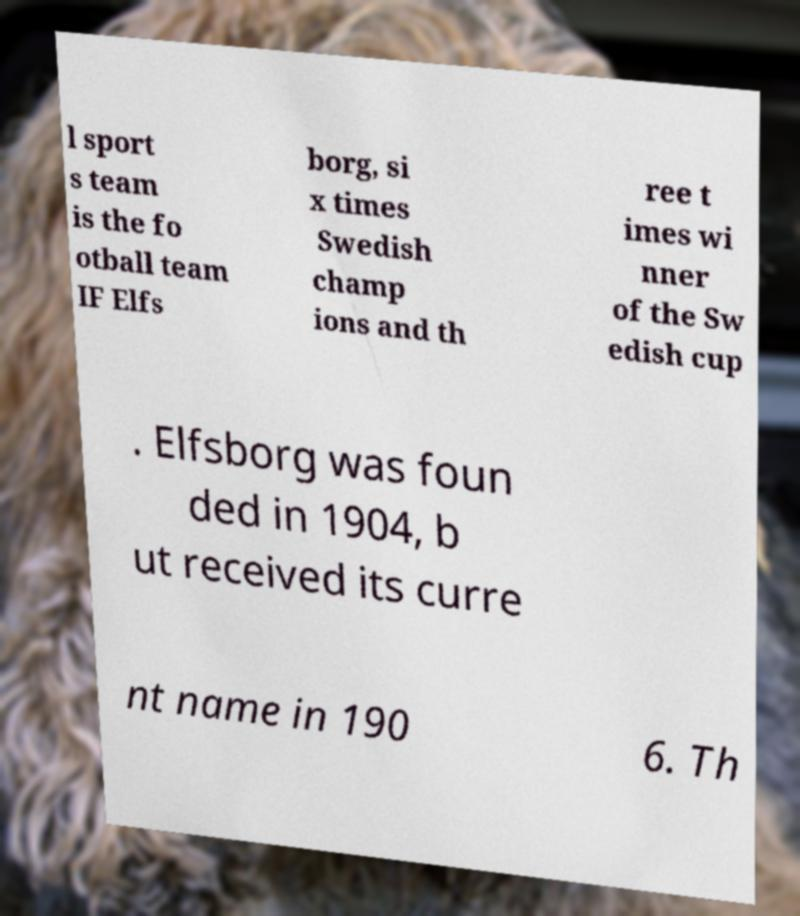I need the written content from this picture converted into text. Can you do that? l sport s team is the fo otball team IF Elfs borg, si x times Swedish champ ions and th ree t imes wi nner of the Sw edish cup . Elfsborg was foun ded in 1904, b ut received its curre nt name in 190 6. Th 